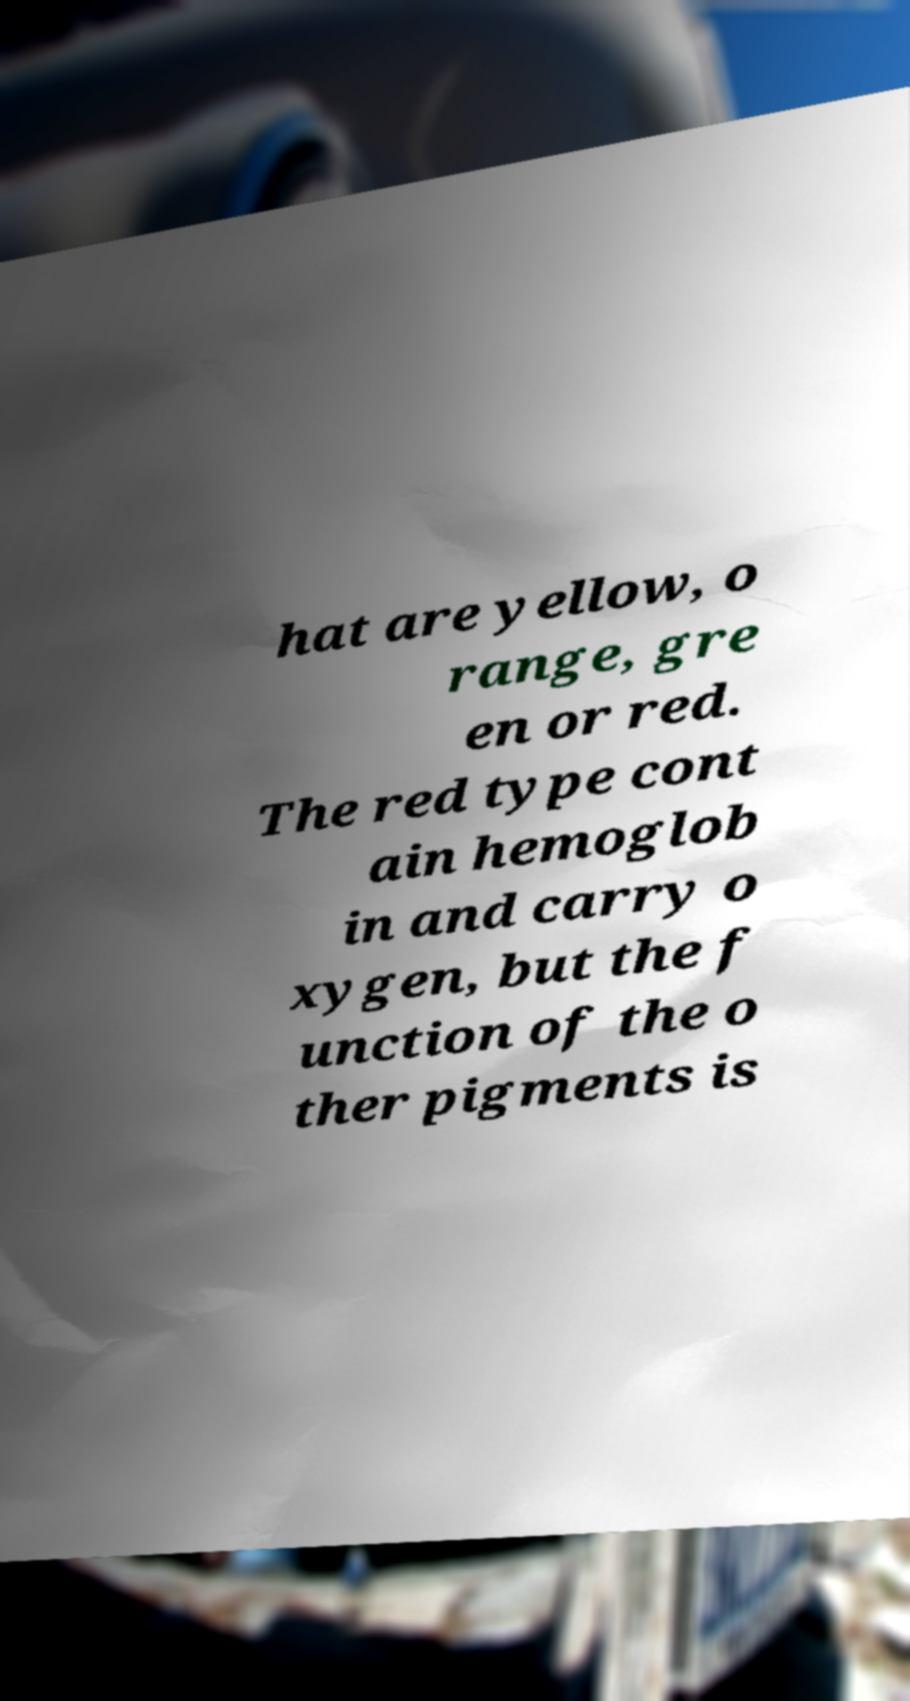Could you assist in decoding the text presented in this image and type it out clearly? hat are yellow, o range, gre en or red. The red type cont ain hemoglob in and carry o xygen, but the f unction of the o ther pigments is 